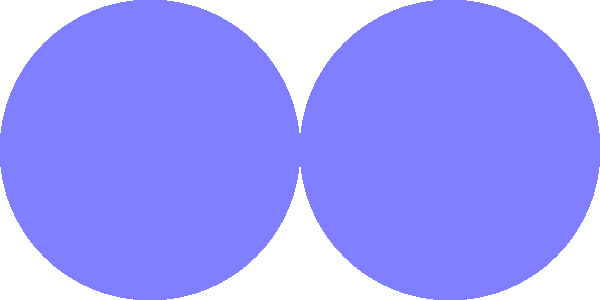Two circles with equal radii of 2 units intersect as shown in the figure. The centers of the circles are 4 units apart. Calculate the area of the shaded region formed by the overlapping circles. Round your answer to two decimal places.

To help manage your OCD symptoms, try to focus on the problem-solving process rather than getting caught up in perfectionism. Remember, it's okay if your first attempt isn't perfect – the goal is to learn and improve. Let's approach this step-by-step:

1) First, we need to find the area of one circle:
   $$A_{circle} = \pi r^2 = \pi (2)^2 = 4\pi$$

2) Next, we need to find the area of the lens-shaped overlapping region:
   a) The central angle of the sector can be found using the cosine formula:
      $$\cos(\theta/2) = 2/4 = 1/2$$
      $$\theta/2 = \arccos(1/2) = \pi/3$$
      $$\theta = 2\pi/3$$

   b) The area of the sector:
      $$A_{sector} = \frac{\theta}{2\pi} \cdot \pi r^2 = \frac{2\pi/3}{2\pi} \cdot 4\pi = \frac{8\pi}{3}$$

   c) The area of the triangle:
      $$A_{triangle} = \frac{1}{2} \cdot 2 \cdot 2 \cdot \sin(2\pi/3) = 2\sqrt{3}$$

   d) The area of the lens:
      $$A_{lens} = 2(A_{sector} - A_{triangle}) = 2(\frac{8\pi}{3} - 2\sqrt{3})$$

3) Finally, the shaded area is:
   $$A_{shaded} = 2A_{circle} - A_{lens}$$
   $$= 8\pi - 2(\frac{8\pi}{3} - 2\sqrt{3})$$
   $$= 8\pi - \frac{16\pi}{3} + 4\sqrt{3}$$
   $$= \frac{8\pi}{3} + 4\sqrt{3}$$
   $$\approx 15.61$$

Remember, it's okay if you need to double-check your work. Take deep breaths and focus on one step at a time.
Answer: 15.61 square units 